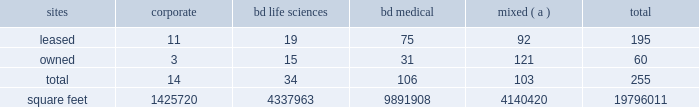The agreements that govern the indebtedness incurred or assumed in connection with the acquisition contain various covenants that impose restrictions on us and certain of our subsidiaries that may affect our ability to operate our businesses .
The agreements that govern the indebtedness incurred or assumed in connection with the carefusion transaction contain various affirmative and negative covenants that may , subject to certain significant exceptions , restrict our ability and the ability of certain of our subsidiaries ( including carefusion ) to , among other things , have liens on their property , transact business with affiliates and/or merge or consolidate with any other person or sell or convey certain of our assets to any one person .
In addition , some of the agreements that govern our indebtedness contain financial covenants that will require us to maintain certain financial ratios .
Our ability and the ability of our subsidiaries to comply with these provisions may be affected by events beyond our control .
Failure to comply with these covenants could result in an event of default , which , if not cured or waived , could accelerate our repayment obligations .
Item 1b .
Unresolved staff comments .
Item 2 .
Properties .
Bd 2019s executive offices are located in franklin lakes , new jersey .
As of october 31 , 2016 , bd owned or leased 255 facilities throughout the world , comprising approximately 19796011 square feet of manufacturing , warehousing , administrative and research facilities .
The u.s .
Facilities , including those in puerto rico , comprise approximately 7459856 square feet of owned and 2923257 square feet of leased space .
The international facilities comprise approximately 7189652 square feet of owned and 2223245 square feet of leased space .
Sales offices and distribution centers included in the total square footage are also located throughout the world .
Operations in each of bd 2019s business segments are conducted at both u.s .
And international locations .
Particularly in the international marketplace , facilities often serve more than one business segment and are used for multiple purposes , such as administrative/sales , manufacturing and/or warehousing/distribution .
Bd generally seeks to own its manufacturing facilities , although some are leased .
The table summarizes property information by business segment. .
( a ) facilities used by more than one business segment .
Bd believes that its facilities are of good construction and in good physical condition , are suitable and adequate for the operations conducted at those facilities , and are , with minor exceptions , fully utilized and operating at normal capacity .
The u.s .
Facilities are located in alabama , arizona , california , connecticut , florida , georgia , illinois , indiana , maryland , massachusetts , michigan , nebraska , new jersey , north carolina , ohio , oklahoma , south carolina , texas , utah , virginia , washington , d.c. , washington , wisconsin and puerto rico .
The international facilities are as follows : - europe , middle east , africa , which includes facilities in austria , belgium , bosnia and herzegovina , the czech republic , denmark , england , finland , france , germany , ghana , hungary , ireland , italy , kenya , luxembourg , netherlands , norway , poland , portugal , russia , saudi arabia , south africa , spain , sweden , switzerland , turkey , the united arab emirates and zambia. .
What percentage of international facilities' square footage is from owned facilities?\\n? 
Computations: (7189652 / (7189652 + 2223245))
Answer: 0.76381. 